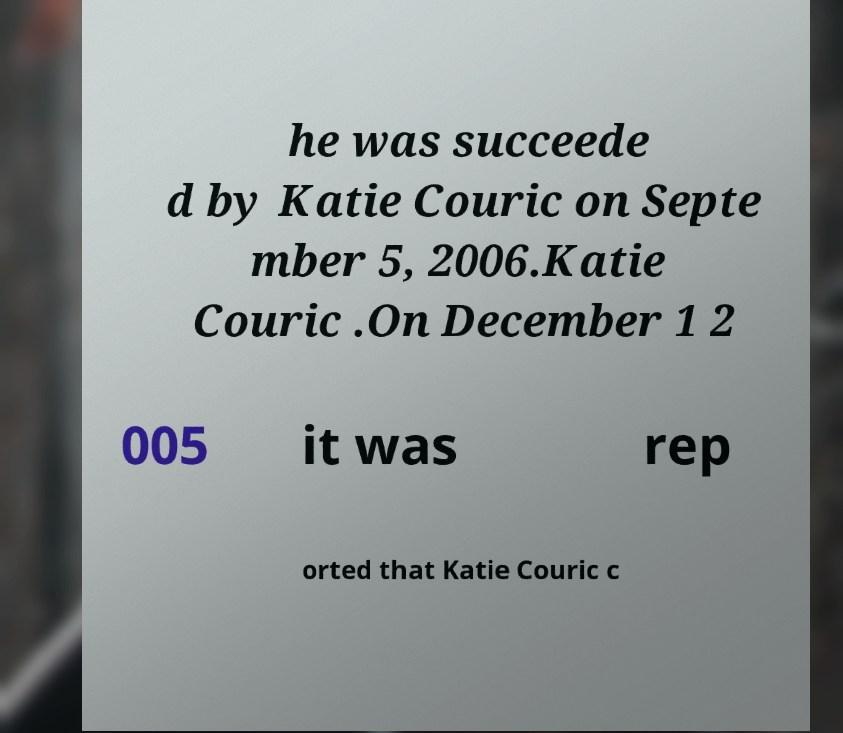I need the written content from this picture converted into text. Can you do that? he was succeede d by Katie Couric on Septe mber 5, 2006.Katie Couric .On December 1 2 005 it was rep orted that Katie Couric c 